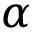<formula> <loc_0><loc_0><loc_500><loc_500>\alpha</formula> 